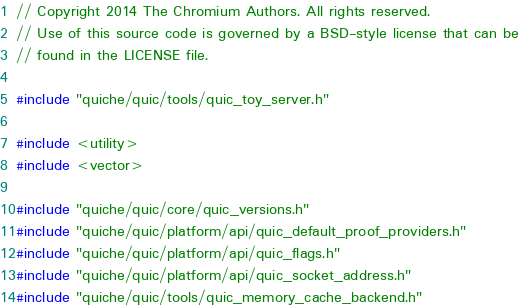<code> <loc_0><loc_0><loc_500><loc_500><_C++_>// Copyright 2014 The Chromium Authors. All rights reserved.
// Use of this source code is governed by a BSD-style license that can be
// found in the LICENSE file.

#include "quiche/quic/tools/quic_toy_server.h"

#include <utility>
#include <vector>

#include "quiche/quic/core/quic_versions.h"
#include "quiche/quic/platform/api/quic_default_proof_providers.h"
#include "quiche/quic/platform/api/quic_flags.h"
#include "quiche/quic/platform/api/quic_socket_address.h"
#include "quiche/quic/tools/quic_memory_cache_backend.h"</code> 